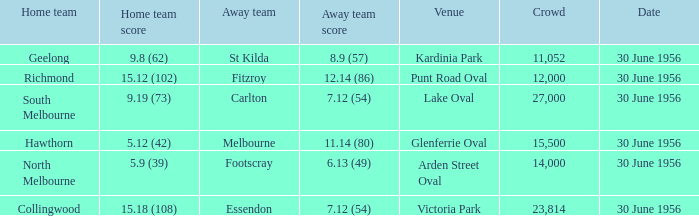What is the home team for punt road oval? Richmond. 